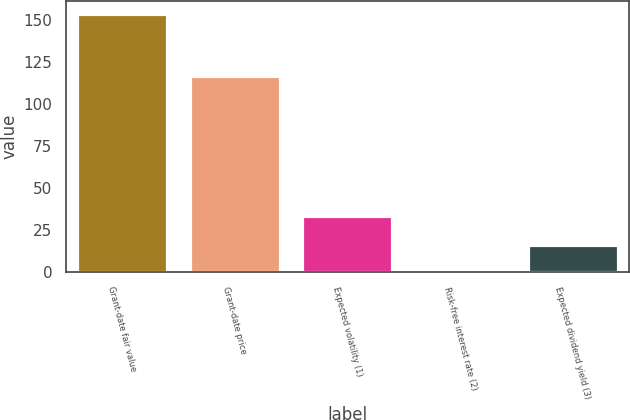Convert chart. <chart><loc_0><loc_0><loc_500><loc_500><bar_chart><fcel>Grant-date fair value<fcel>Grant-date price<fcel>Expected volatility (1)<fcel>Risk-free interest rate (2)<fcel>Expected dividend yield (3)<nl><fcel>153.64<fcel>117.08<fcel>33.5<fcel>0.9<fcel>16.17<nl></chart> 